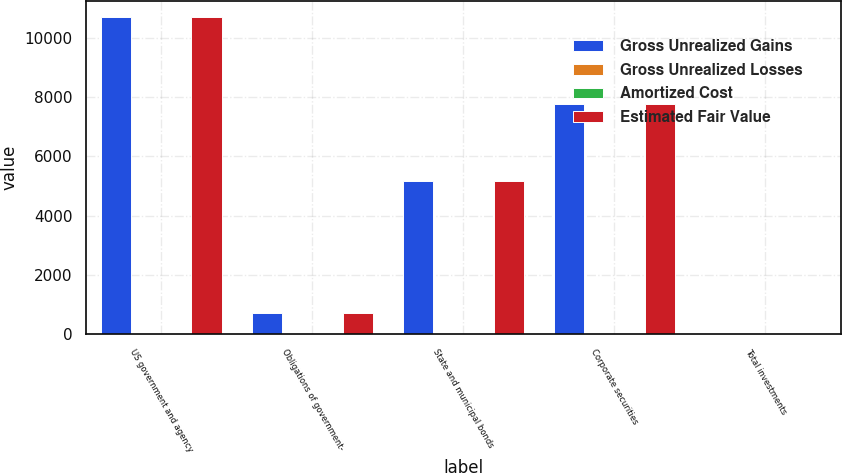Convert chart. <chart><loc_0><loc_0><loc_500><loc_500><stacked_bar_chart><ecel><fcel>US government and agency<fcel>Obligations of government-<fcel>State and municipal bonds<fcel>Corporate securities<fcel>Total investments<nl><fcel>Gross Unrealized Gains<fcel>10720<fcel>705<fcel>5156<fcel>7779<fcel>33<nl><fcel>Gross Unrealized Losses<fcel>0<fcel>0<fcel>27<fcel>12<fcel>39<nl><fcel>Amortized Cost<fcel>0<fcel>0<fcel>4<fcel>10<fcel>14<nl><fcel>Estimated Fair Value<fcel>10720<fcel>705<fcel>5179<fcel>7781<fcel>33<nl></chart> 